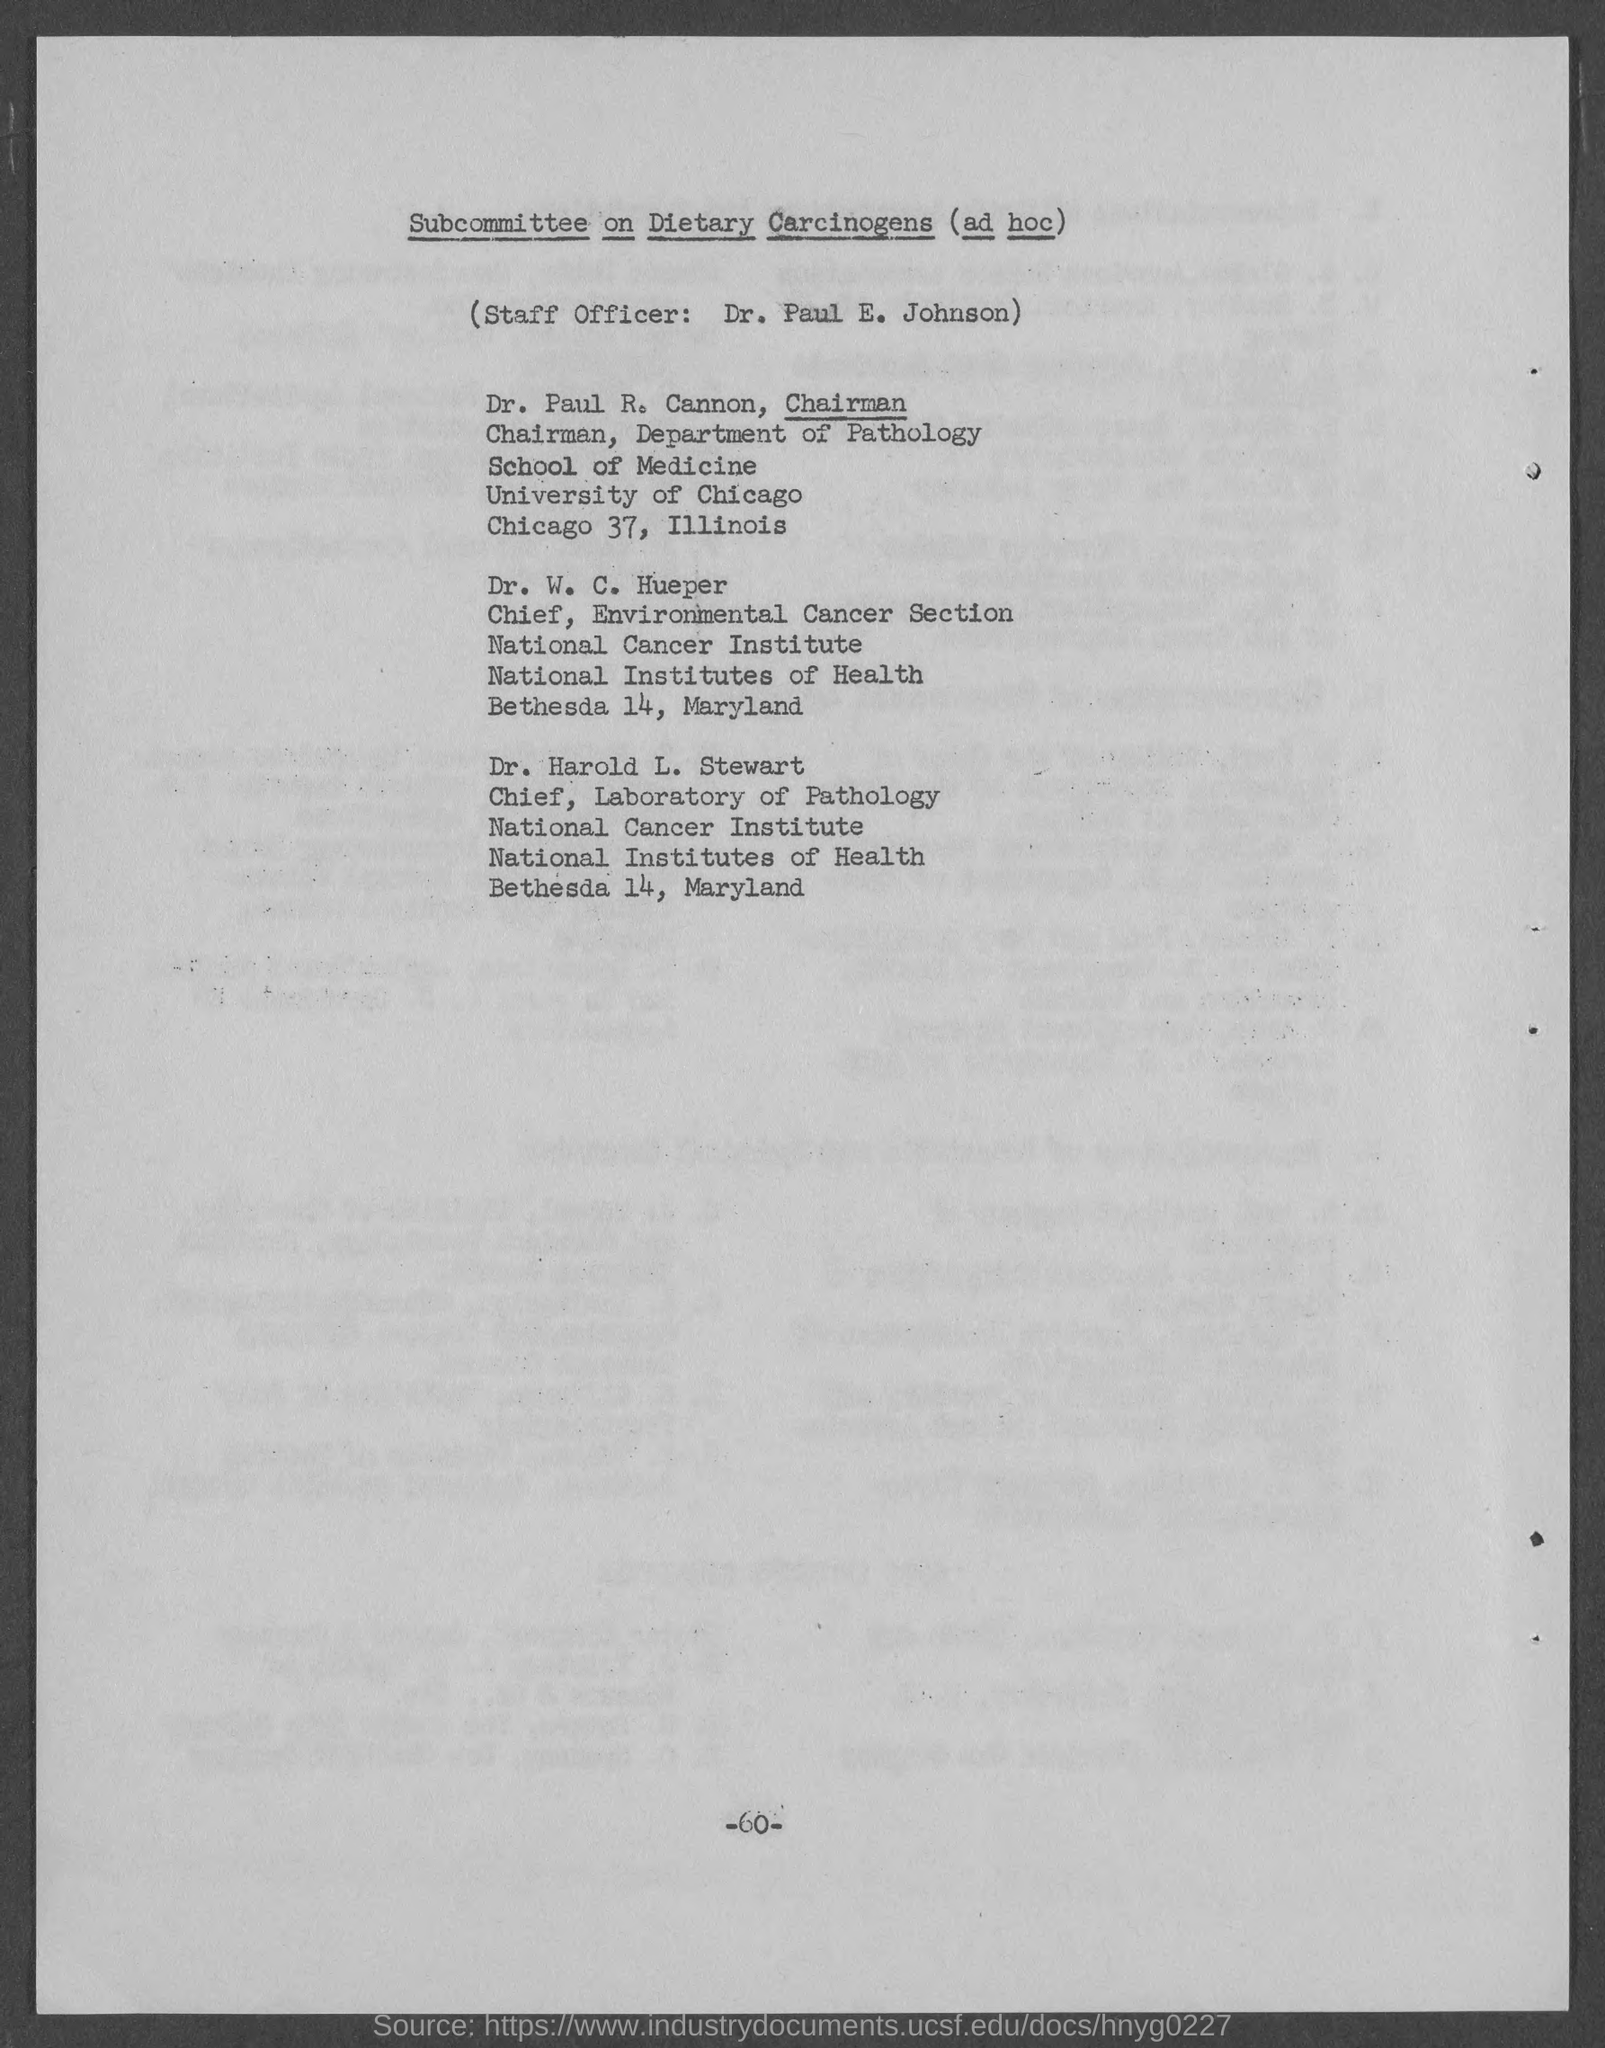Outline some significant characteristics in this image. The Chief of the Laboratory of Pathology at the National Cancer Institute is Dr. Harold L. Stewart. 